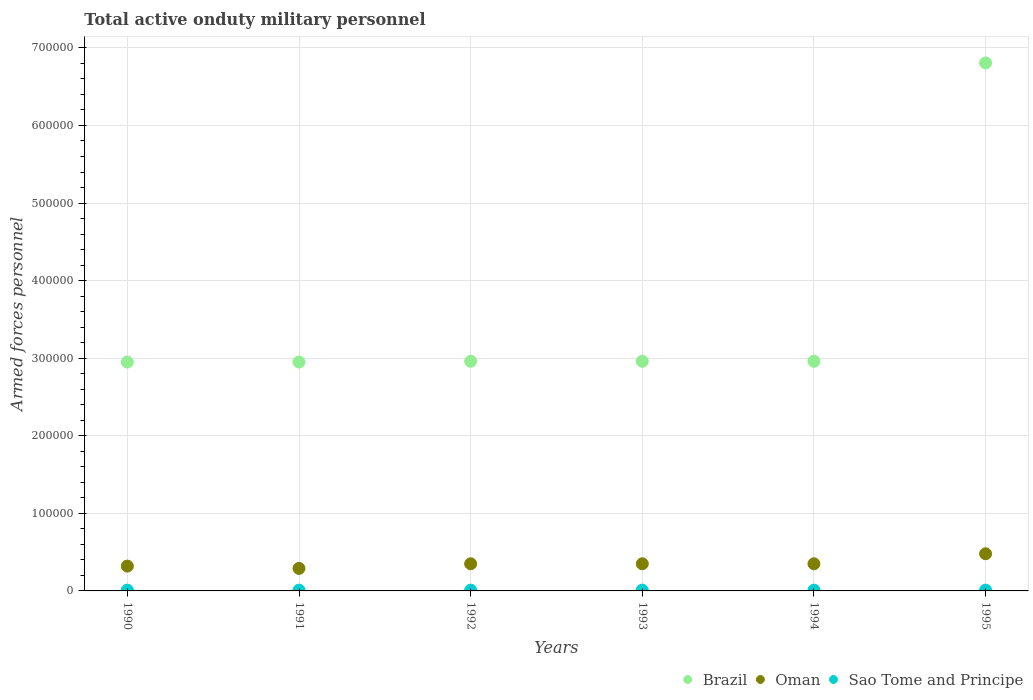What is the number of armed forces personnel in Brazil in 1995?
Keep it short and to the point. 6.81e+05. Across all years, what is the maximum number of armed forces personnel in Brazil?
Provide a short and direct response. 6.81e+05. Across all years, what is the minimum number of armed forces personnel in Sao Tome and Principe?
Ensure brevity in your answer.  1000. In which year was the number of armed forces personnel in Oman maximum?
Keep it short and to the point. 1995. In which year was the number of armed forces personnel in Sao Tome and Principe minimum?
Your answer should be compact. 1990. What is the total number of armed forces personnel in Brazil in the graph?
Give a very brief answer. 2.16e+06. What is the difference between the number of armed forces personnel in Oman in 1993 and the number of armed forces personnel in Brazil in 1991?
Provide a succinct answer. -2.60e+05. What is the average number of armed forces personnel in Brazil per year?
Make the answer very short. 3.60e+05. In the year 1995, what is the difference between the number of armed forces personnel in Oman and number of armed forces personnel in Brazil?
Your response must be concise. -6.33e+05. What is the ratio of the number of armed forces personnel in Oman in 1993 to that in 1995?
Your response must be concise. 0.73. Is the difference between the number of armed forces personnel in Oman in 1992 and 1994 greater than the difference between the number of armed forces personnel in Brazil in 1992 and 1994?
Provide a succinct answer. No. What is the difference between the highest and the second highest number of armed forces personnel in Oman?
Provide a succinct answer. 1.29e+04. What is the difference between the highest and the lowest number of armed forces personnel in Brazil?
Your response must be concise. 3.86e+05. In how many years, is the number of armed forces personnel in Brazil greater than the average number of armed forces personnel in Brazil taken over all years?
Provide a succinct answer. 1. Is it the case that in every year, the sum of the number of armed forces personnel in Oman and number of armed forces personnel in Sao Tome and Principe  is greater than the number of armed forces personnel in Brazil?
Ensure brevity in your answer.  No. Is the number of armed forces personnel in Brazil strictly greater than the number of armed forces personnel in Oman over the years?
Give a very brief answer. Yes. Is the number of armed forces personnel in Sao Tome and Principe strictly less than the number of armed forces personnel in Brazil over the years?
Your answer should be very brief. Yes. How many dotlines are there?
Ensure brevity in your answer.  3. What is the difference between two consecutive major ticks on the Y-axis?
Offer a very short reply. 1.00e+05. Does the graph contain any zero values?
Your response must be concise. No. Does the graph contain grids?
Offer a very short reply. Yes. How many legend labels are there?
Ensure brevity in your answer.  3. What is the title of the graph?
Give a very brief answer. Total active onduty military personnel. What is the label or title of the X-axis?
Provide a succinct answer. Years. What is the label or title of the Y-axis?
Your answer should be very brief. Armed forces personnel. What is the Armed forces personnel in Brazil in 1990?
Your answer should be very brief. 2.95e+05. What is the Armed forces personnel of Oman in 1990?
Make the answer very short. 3.20e+04. What is the Armed forces personnel of Sao Tome and Principe in 1990?
Offer a terse response. 1000. What is the Armed forces personnel in Brazil in 1991?
Offer a terse response. 2.95e+05. What is the Armed forces personnel in Oman in 1991?
Give a very brief answer. 2.90e+04. What is the Armed forces personnel of Brazil in 1992?
Ensure brevity in your answer.  2.96e+05. What is the Armed forces personnel of Oman in 1992?
Provide a succinct answer. 3.50e+04. What is the Armed forces personnel in Brazil in 1993?
Provide a short and direct response. 2.96e+05. What is the Armed forces personnel of Oman in 1993?
Make the answer very short. 3.50e+04. What is the Armed forces personnel of Brazil in 1994?
Give a very brief answer. 2.96e+05. What is the Armed forces personnel of Oman in 1994?
Offer a terse response. 3.50e+04. What is the Armed forces personnel in Brazil in 1995?
Offer a terse response. 6.81e+05. What is the Armed forces personnel in Oman in 1995?
Your answer should be very brief. 4.79e+04. What is the Armed forces personnel of Sao Tome and Principe in 1995?
Your response must be concise. 1000. Across all years, what is the maximum Armed forces personnel of Brazil?
Provide a short and direct response. 6.81e+05. Across all years, what is the maximum Armed forces personnel in Oman?
Offer a very short reply. 4.79e+04. Across all years, what is the minimum Armed forces personnel in Brazil?
Give a very brief answer. 2.95e+05. Across all years, what is the minimum Armed forces personnel in Oman?
Offer a terse response. 2.90e+04. Across all years, what is the minimum Armed forces personnel in Sao Tome and Principe?
Give a very brief answer. 1000. What is the total Armed forces personnel of Brazil in the graph?
Provide a short and direct response. 2.16e+06. What is the total Armed forces personnel of Oman in the graph?
Your answer should be compact. 2.14e+05. What is the total Armed forces personnel of Sao Tome and Principe in the graph?
Provide a succinct answer. 6000. What is the difference between the Armed forces personnel in Brazil in 1990 and that in 1991?
Your answer should be very brief. 0. What is the difference between the Armed forces personnel in Oman in 1990 and that in 1991?
Offer a terse response. 3000. What is the difference between the Armed forces personnel in Sao Tome and Principe in 1990 and that in 1991?
Ensure brevity in your answer.  0. What is the difference between the Armed forces personnel of Brazil in 1990 and that in 1992?
Give a very brief answer. -1000. What is the difference between the Armed forces personnel in Oman in 1990 and that in 1992?
Make the answer very short. -3000. What is the difference between the Armed forces personnel of Brazil in 1990 and that in 1993?
Your response must be concise. -1000. What is the difference between the Armed forces personnel in Oman in 1990 and that in 1993?
Make the answer very short. -3000. What is the difference between the Armed forces personnel of Brazil in 1990 and that in 1994?
Ensure brevity in your answer.  -1000. What is the difference between the Armed forces personnel of Oman in 1990 and that in 1994?
Provide a short and direct response. -3000. What is the difference between the Armed forces personnel of Brazil in 1990 and that in 1995?
Ensure brevity in your answer.  -3.86e+05. What is the difference between the Armed forces personnel in Oman in 1990 and that in 1995?
Keep it short and to the point. -1.59e+04. What is the difference between the Armed forces personnel of Brazil in 1991 and that in 1992?
Offer a terse response. -1000. What is the difference between the Armed forces personnel of Oman in 1991 and that in 1992?
Offer a terse response. -6000. What is the difference between the Armed forces personnel of Sao Tome and Principe in 1991 and that in 1992?
Offer a very short reply. 0. What is the difference between the Armed forces personnel in Brazil in 1991 and that in 1993?
Give a very brief answer. -1000. What is the difference between the Armed forces personnel of Oman in 1991 and that in 1993?
Offer a very short reply. -6000. What is the difference between the Armed forces personnel of Brazil in 1991 and that in 1994?
Your answer should be compact. -1000. What is the difference between the Armed forces personnel in Oman in 1991 and that in 1994?
Give a very brief answer. -6000. What is the difference between the Armed forces personnel in Sao Tome and Principe in 1991 and that in 1994?
Ensure brevity in your answer.  0. What is the difference between the Armed forces personnel in Brazil in 1991 and that in 1995?
Provide a succinct answer. -3.86e+05. What is the difference between the Armed forces personnel in Oman in 1991 and that in 1995?
Give a very brief answer. -1.89e+04. What is the difference between the Armed forces personnel in Sao Tome and Principe in 1991 and that in 1995?
Provide a short and direct response. 0. What is the difference between the Armed forces personnel of Brazil in 1992 and that in 1993?
Provide a succinct answer. 0. What is the difference between the Armed forces personnel of Sao Tome and Principe in 1992 and that in 1993?
Offer a very short reply. 0. What is the difference between the Armed forces personnel of Brazil in 1992 and that in 1994?
Your answer should be compact. 0. What is the difference between the Armed forces personnel of Oman in 1992 and that in 1994?
Keep it short and to the point. 0. What is the difference between the Armed forces personnel in Brazil in 1992 and that in 1995?
Your response must be concise. -3.85e+05. What is the difference between the Armed forces personnel in Oman in 1992 and that in 1995?
Offer a terse response. -1.29e+04. What is the difference between the Armed forces personnel in Sao Tome and Principe in 1992 and that in 1995?
Ensure brevity in your answer.  0. What is the difference between the Armed forces personnel in Brazil in 1993 and that in 1994?
Your response must be concise. 0. What is the difference between the Armed forces personnel of Oman in 1993 and that in 1994?
Provide a succinct answer. 0. What is the difference between the Armed forces personnel of Brazil in 1993 and that in 1995?
Your response must be concise. -3.85e+05. What is the difference between the Armed forces personnel of Oman in 1993 and that in 1995?
Your answer should be very brief. -1.29e+04. What is the difference between the Armed forces personnel of Sao Tome and Principe in 1993 and that in 1995?
Offer a terse response. 0. What is the difference between the Armed forces personnel of Brazil in 1994 and that in 1995?
Give a very brief answer. -3.85e+05. What is the difference between the Armed forces personnel of Oman in 1994 and that in 1995?
Ensure brevity in your answer.  -1.29e+04. What is the difference between the Armed forces personnel in Sao Tome and Principe in 1994 and that in 1995?
Your answer should be very brief. 0. What is the difference between the Armed forces personnel in Brazil in 1990 and the Armed forces personnel in Oman in 1991?
Offer a very short reply. 2.66e+05. What is the difference between the Armed forces personnel in Brazil in 1990 and the Armed forces personnel in Sao Tome and Principe in 1991?
Keep it short and to the point. 2.94e+05. What is the difference between the Armed forces personnel in Oman in 1990 and the Armed forces personnel in Sao Tome and Principe in 1991?
Make the answer very short. 3.10e+04. What is the difference between the Armed forces personnel of Brazil in 1990 and the Armed forces personnel of Oman in 1992?
Keep it short and to the point. 2.60e+05. What is the difference between the Armed forces personnel in Brazil in 1990 and the Armed forces personnel in Sao Tome and Principe in 1992?
Offer a very short reply. 2.94e+05. What is the difference between the Armed forces personnel of Oman in 1990 and the Armed forces personnel of Sao Tome and Principe in 1992?
Provide a short and direct response. 3.10e+04. What is the difference between the Armed forces personnel in Brazil in 1990 and the Armed forces personnel in Oman in 1993?
Provide a short and direct response. 2.60e+05. What is the difference between the Armed forces personnel in Brazil in 1990 and the Armed forces personnel in Sao Tome and Principe in 1993?
Offer a terse response. 2.94e+05. What is the difference between the Armed forces personnel in Oman in 1990 and the Armed forces personnel in Sao Tome and Principe in 1993?
Make the answer very short. 3.10e+04. What is the difference between the Armed forces personnel in Brazil in 1990 and the Armed forces personnel in Oman in 1994?
Offer a very short reply. 2.60e+05. What is the difference between the Armed forces personnel in Brazil in 1990 and the Armed forces personnel in Sao Tome and Principe in 1994?
Offer a very short reply. 2.94e+05. What is the difference between the Armed forces personnel of Oman in 1990 and the Armed forces personnel of Sao Tome and Principe in 1994?
Ensure brevity in your answer.  3.10e+04. What is the difference between the Armed forces personnel in Brazil in 1990 and the Armed forces personnel in Oman in 1995?
Ensure brevity in your answer.  2.47e+05. What is the difference between the Armed forces personnel of Brazil in 1990 and the Armed forces personnel of Sao Tome and Principe in 1995?
Provide a succinct answer. 2.94e+05. What is the difference between the Armed forces personnel in Oman in 1990 and the Armed forces personnel in Sao Tome and Principe in 1995?
Your answer should be compact. 3.10e+04. What is the difference between the Armed forces personnel in Brazil in 1991 and the Armed forces personnel in Oman in 1992?
Offer a terse response. 2.60e+05. What is the difference between the Armed forces personnel of Brazil in 1991 and the Armed forces personnel of Sao Tome and Principe in 1992?
Provide a short and direct response. 2.94e+05. What is the difference between the Armed forces personnel in Oman in 1991 and the Armed forces personnel in Sao Tome and Principe in 1992?
Your answer should be compact. 2.80e+04. What is the difference between the Armed forces personnel of Brazil in 1991 and the Armed forces personnel of Sao Tome and Principe in 1993?
Your answer should be very brief. 2.94e+05. What is the difference between the Armed forces personnel of Oman in 1991 and the Armed forces personnel of Sao Tome and Principe in 1993?
Give a very brief answer. 2.80e+04. What is the difference between the Armed forces personnel in Brazil in 1991 and the Armed forces personnel in Sao Tome and Principe in 1994?
Provide a short and direct response. 2.94e+05. What is the difference between the Armed forces personnel of Oman in 1991 and the Armed forces personnel of Sao Tome and Principe in 1994?
Offer a terse response. 2.80e+04. What is the difference between the Armed forces personnel of Brazil in 1991 and the Armed forces personnel of Oman in 1995?
Offer a terse response. 2.47e+05. What is the difference between the Armed forces personnel of Brazil in 1991 and the Armed forces personnel of Sao Tome and Principe in 1995?
Provide a succinct answer. 2.94e+05. What is the difference between the Armed forces personnel of Oman in 1991 and the Armed forces personnel of Sao Tome and Principe in 1995?
Your answer should be compact. 2.80e+04. What is the difference between the Armed forces personnel of Brazil in 1992 and the Armed forces personnel of Oman in 1993?
Offer a terse response. 2.61e+05. What is the difference between the Armed forces personnel of Brazil in 1992 and the Armed forces personnel of Sao Tome and Principe in 1993?
Your answer should be compact. 2.95e+05. What is the difference between the Armed forces personnel of Oman in 1992 and the Armed forces personnel of Sao Tome and Principe in 1993?
Keep it short and to the point. 3.40e+04. What is the difference between the Armed forces personnel of Brazil in 1992 and the Armed forces personnel of Oman in 1994?
Your response must be concise. 2.61e+05. What is the difference between the Armed forces personnel in Brazil in 1992 and the Armed forces personnel in Sao Tome and Principe in 1994?
Your response must be concise. 2.95e+05. What is the difference between the Armed forces personnel in Oman in 1992 and the Armed forces personnel in Sao Tome and Principe in 1994?
Ensure brevity in your answer.  3.40e+04. What is the difference between the Armed forces personnel of Brazil in 1992 and the Armed forces personnel of Oman in 1995?
Give a very brief answer. 2.48e+05. What is the difference between the Armed forces personnel in Brazil in 1992 and the Armed forces personnel in Sao Tome and Principe in 1995?
Ensure brevity in your answer.  2.95e+05. What is the difference between the Armed forces personnel of Oman in 1992 and the Armed forces personnel of Sao Tome and Principe in 1995?
Your answer should be very brief. 3.40e+04. What is the difference between the Armed forces personnel in Brazil in 1993 and the Armed forces personnel in Oman in 1994?
Your answer should be very brief. 2.61e+05. What is the difference between the Armed forces personnel of Brazil in 1993 and the Armed forces personnel of Sao Tome and Principe in 1994?
Give a very brief answer. 2.95e+05. What is the difference between the Armed forces personnel in Oman in 1993 and the Armed forces personnel in Sao Tome and Principe in 1994?
Offer a very short reply. 3.40e+04. What is the difference between the Armed forces personnel of Brazil in 1993 and the Armed forces personnel of Oman in 1995?
Give a very brief answer. 2.48e+05. What is the difference between the Armed forces personnel in Brazil in 1993 and the Armed forces personnel in Sao Tome and Principe in 1995?
Provide a succinct answer. 2.95e+05. What is the difference between the Armed forces personnel of Oman in 1993 and the Armed forces personnel of Sao Tome and Principe in 1995?
Give a very brief answer. 3.40e+04. What is the difference between the Armed forces personnel of Brazil in 1994 and the Armed forces personnel of Oman in 1995?
Offer a terse response. 2.48e+05. What is the difference between the Armed forces personnel in Brazil in 1994 and the Armed forces personnel in Sao Tome and Principe in 1995?
Ensure brevity in your answer.  2.95e+05. What is the difference between the Armed forces personnel in Oman in 1994 and the Armed forces personnel in Sao Tome and Principe in 1995?
Your answer should be compact. 3.40e+04. What is the average Armed forces personnel in Brazil per year?
Keep it short and to the point. 3.60e+05. What is the average Armed forces personnel of Oman per year?
Ensure brevity in your answer.  3.56e+04. In the year 1990, what is the difference between the Armed forces personnel in Brazil and Armed forces personnel in Oman?
Your answer should be very brief. 2.63e+05. In the year 1990, what is the difference between the Armed forces personnel in Brazil and Armed forces personnel in Sao Tome and Principe?
Your response must be concise. 2.94e+05. In the year 1990, what is the difference between the Armed forces personnel of Oman and Armed forces personnel of Sao Tome and Principe?
Make the answer very short. 3.10e+04. In the year 1991, what is the difference between the Armed forces personnel in Brazil and Armed forces personnel in Oman?
Your answer should be compact. 2.66e+05. In the year 1991, what is the difference between the Armed forces personnel of Brazil and Armed forces personnel of Sao Tome and Principe?
Your response must be concise. 2.94e+05. In the year 1991, what is the difference between the Armed forces personnel in Oman and Armed forces personnel in Sao Tome and Principe?
Your answer should be compact. 2.80e+04. In the year 1992, what is the difference between the Armed forces personnel in Brazil and Armed forces personnel in Oman?
Give a very brief answer. 2.61e+05. In the year 1992, what is the difference between the Armed forces personnel of Brazil and Armed forces personnel of Sao Tome and Principe?
Keep it short and to the point. 2.95e+05. In the year 1992, what is the difference between the Armed forces personnel of Oman and Armed forces personnel of Sao Tome and Principe?
Ensure brevity in your answer.  3.40e+04. In the year 1993, what is the difference between the Armed forces personnel in Brazil and Armed forces personnel in Oman?
Keep it short and to the point. 2.61e+05. In the year 1993, what is the difference between the Armed forces personnel of Brazil and Armed forces personnel of Sao Tome and Principe?
Keep it short and to the point. 2.95e+05. In the year 1993, what is the difference between the Armed forces personnel of Oman and Armed forces personnel of Sao Tome and Principe?
Give a very brief answer. 3.40e+04. In the year 1994, what is the difference between the Armed forces personnel in Brazil and Armed forces personnel in Oman?
Provide a short and direct response. 2.61e+05. In the year 1994, what is the difference between the Armed forces personnel of Brazil and Armed forces personnel of Sao Tome and Principe?
Offer a terse response. 2.95e+05. In the year 1994, what is the difference between the Armed forces personnel of Oman and Armed forces personnel of Sao Tome and Principe?
Offer a very short reply. 3.40e+04. In the year 1995, what is the difference between the Armed forces personnel of Brazil and Armed forces personnel of Oman?
Give a very brief answer. 6.33e+05. In the year 1995, what is the difference between the Armed forces personnel in Brazil and Armed forces personnel in Sao Tome and Principe?
Make the answer very short. 6.80e+05. In the year 1995, what is the difference between the Armed forces personnel in Oman and Armed forces personnel in Sao Tome and Principe?
Your answer should be very brief. 4.69e+04. What is the ratio of the Armed forces personnel in Oman in 1990 to that in 1991?
Your response must be concise. 1.1. What is the ratio of the Armed forces personnel in Brazil in 1990 to that in 1992?
Offer a terse response. 1. What is the ratio of the Armed forces personnel in Oman in 1990 to that in 1992?
Provide a short and direct response. 0.91. What is the ratio of the Armed forces personnel of Brazil in 1990 to that in 1993?
Make the answer very short. 1. What is the ratio of the Armed forces personnel of Oman in 1990 to that in 1993?
Provide a succinct answer. 0.91. What is the ratio of the Armed forces personnel in Sao Tome and Principe in 1990 to that in 1993?
Your response must be concise. 1. What is the ratio of the Armed forces personnel of Brazil in 1990 to that in 1994?
Keep it short and to the point. 1. What is the ratio of the Armed forces personnel of Oman in 1990 to that in 1994?
Ensure brevity in your answer.  0.91. What is the ratio of the Armed forces personnel of Brazil in 1990 to that in 1995?
Give a very brief answer. 0.43. What is the ratio of the Armed forces personnel in Oman in 1990 to that in 1995?
Offer a terse response. 0.67. What is the ratio of the Armed forces personnel of Sao Tome and Principe in 1990 to that in 1995?
Your answer should be very brief. 1. What is the ratio of the Armed forces personnel of Oman in 1991 to that in 1992?
Your response must be concise. 0.83. What is the ratio of the Armed forces personnel of Brazil in 1991 to that in 1993?
Provide a succinct answer. 1. What is the ratio of the Armed forces personnel of Oman in 1991 to that in 1993?
Provide a short and direct response. 0.83. What is the ratio of the Armed forces personnel of Brazil in 1991 to that in 1994?
Offer a very short reply. 1. What is the ratio of the Armed forces personnel of Oman in 1991 to that in 1994?
Keep it short and to the point. 0.83. What is the ratio of the Armed forces personnel of Brazil in 1991 to that in 1995?
Provide a short and direct response. 0.43. What is the ratio of the Armed forces personnel in Oman in 1991 to that in 1995?
Offer a terse response. 0.61. What is the ratio of the Armed forces personnel of Sao Tome and Principe in 1991 to that in 1995?
Provide a succinct answer. 1. What is the ratio of the Armed forces personnel of Brazil in 1992 to that in 1993?
Provide a short and direct response. 1. What is the ratio of the Armed forces personnel of Sao Tome and Principe in 1992 to that in 1993?
Ensure brevity in your answer.  1. What is the ratio of the Armed forces personnel of Sao Tome and Principe in 1992 to that in 1994?
Your answer should be very brief. 1. What is the ratio of the Armed forces personnel of Brazil in 1992 to that in 1995?
Provide a short and direct response. 0.43. What is the ratio of the Armed forces personnel in Oman in 1992 to that in 1995?
Provide a succinct answer. 0.73. What is the ratio of the Armed forces personnel in Oman in 1993 to that in 1994?
Make the answer very short. 1. What is the ratio of the Armed forces personnel of Brazil in 1993 to that in 1995?
Make the answer very short. 0.43. What is the ratio of the Armed forces personnel in Oman in 1993 to that in 1995?
Your answer should be very brief. 0.73. What is the ratio of the Armed forces personnel of Sao Tome and Principe in 1993 to that in 1995?
Your answer should be very brief. 1. What is the ratio of the Armed forces personnel of Brazil in 1994 to that in 1995?
Offer a terse response. 0.43. What is the ratio of the Armed forces personnel of Oman in 1994 to that in 1995?
Your answer should be very brief. 0.73. What is the ratio of the Armed forces personnel in Sao Tome and Principe in 1994 to that in 1995?
Your answer should be compact. 1. What is the difference between the highest and the second highest Armed forces personnel in Brazil?
Provide a short and direct response. 3.85e+05. What is the difference between the highest and the second highest Armed forces personnel of Oman?
Give a very brief answer. 1.29e+04. What is the difference between the highest and the second highest Armed forces personnel in Sao Tome and Principe?
Ensure brevity in your answer.  0. What is the difference between the highest and the lowest Armed forces personnel in Brazil?
Provide a short and direct response. 3.86e+05. What is the difference between the highest and the lowest Armed forces personnel in Oman?
Provide a short and direct response. 1.89e+04. What is the difference between the highest and the lowest Armed forces personnel of Sao Tome and Principe?
Offer a very short reply. 0. 